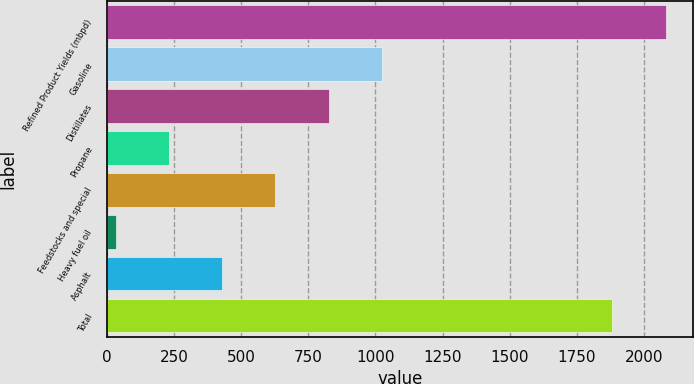Convert chart. <chart><loc_0><loc_0><loc_500><loc_500><bar_chart><fcel>Refined Product Yields (mbpd)<fcel>Gasoline<fcel>Distillates<fcel>Propane<fcel>Feedstocks and special<fcel>Heavy fuel oil<fcel>Asphalt<fcel>Total<nl><fcel>2081.4<fcel>1024<fcel>825.6<fcel>230.4<fcel>627.2<fcel>32<fcel>428.8<fcel>1883<nl></chart> 